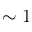<formula> <loc_0><loc_0><loc_500><loc_500>\sim 1</formula> 